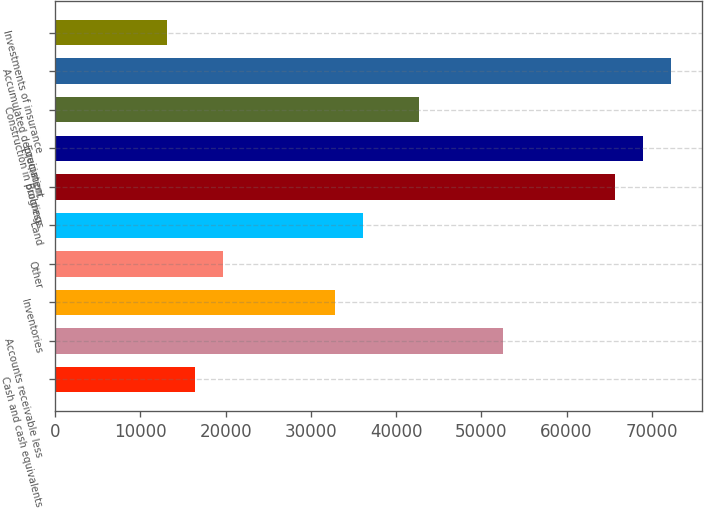Convert chart to OTSL. <chart><loc_0><loc_0><loc_500><loc_500><bar_chart><fcel>Cash and cash equivalents<fcel>Accounts receivable less<fcel>Inventories<fcel>Other<fcel>Land<fcel>Buildings<fcel>Equipment<fcel>Construction in progress<fcel>Accumulated depreciation<fcel>Investments of insurance<nl><fcel>16431<fcel>52570.4<fcel>32858<fcel>19716.4<fcel>36143.4<fcel>65712<fcel>68997.4<fcel>42714.2<fcel>72282.8<fcel>13145.6<nl></chart> 